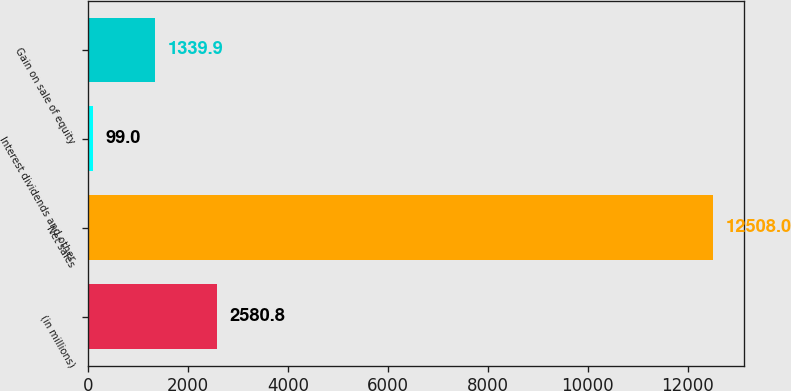Convert chart. <chart><loc_0><loc_0><loc_500><loc_500><bar_chart><fcel>(in millions)<fcel>Net sales<fcel>Interest dividends and other<fcel>Gain on sale of equity<nl><fcel>2580.8<fcel>12508<fcel>99<fcel>1339.9<nl></chart> 